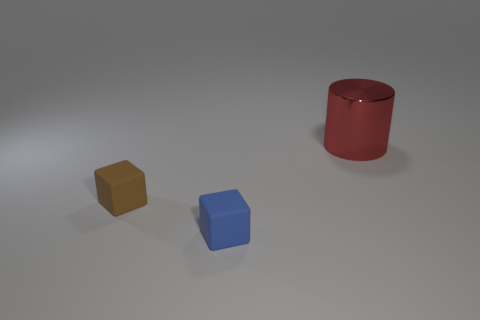Subtract all brown blocks. How many blocks are left? 1 Subtract all blocks. How many objects are left? 1 Add 2 tiny brown rubber things. How many objects exist? 5 Subtract all brown objects. Subtract all big things. How many objects are left? 1 Add 2 big red metal cylinders. How many big red metal cylinders are left? 3 Add 2 large blue rubber balls. How many large blue rubber balls exist? 2 Subtract 0 blue cylinders. How many objects are left? 3 Subtract all gray blocks. Subtract all purple spheres. How many blocks are left? 2 Subtract all red balls. How many gray cylinders are left? 0 